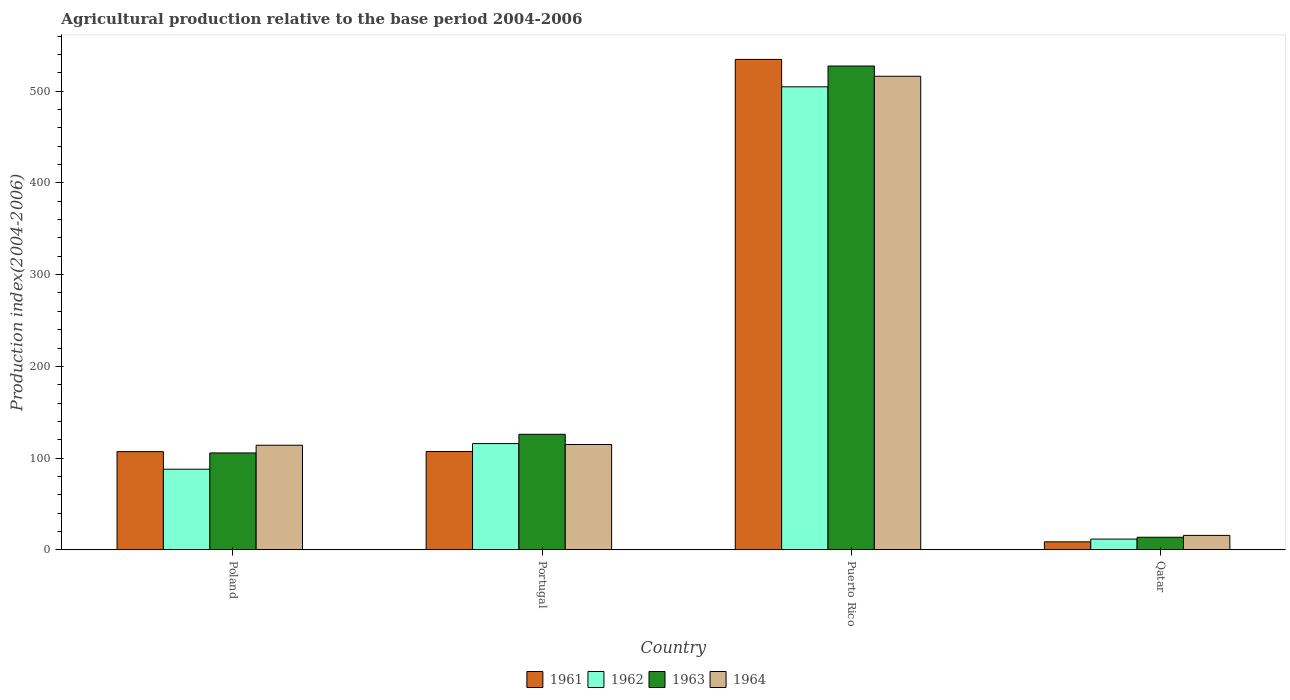How many different coloured bars are there?
Keep it short and to the point. 4. Are the number of bars per tick equal to the number of legend labels?
Offer a very short reply. Yes. How many bars are there on the 4th tick from the right?
Provide a succinct answer. 4. What is the label of the 3rd group of bars from the left?
Offer a terse response. Puerto Rico. What is the agricultural production index in 1961 in Portugal?
Provide a short and direct response. 107.18. Across all countries, what is the maximum agricultural production index in 1962?
Offer a terse response. 504.71. Across all countries, what is the minimum agricultural production index in 1961?
Offer a terse response. 8.73. In which country was the agricultural production index in 1961 maximum?
Your answer should be very brief. Puerto Rico. In which country was the agricultural production index in 1963 minimum?
Offer a very short reply. Qatar. What is the total agricultural production index in 1963 in the graph?
Ensure brevity in your answer.  772.68. What is the difference between the agricultural production index in 1962 in Poland and that in Qatar?
Give a very brief answer. 76.17. What is the difference between the agricultural production index in 1964 in Poland and the agricultural production index in 1963 in Portugal?
Your response must be concise. -11.92. What is the average agricultural production index in 1963 per country?
Your answer should be compact. 193.17. What is the difference between the agricultural production index of/in 1963 and agricultural production index of/in 1962 in Puerto Rico?
Offer a very short reply. 22.67. What is the ratio of the agricultural production index in 1964 in Portugal to that in Puerto Rico?
Offer a terse response. 0.22. Is the difference between the agricultural production index in 1963 in Poland and Qatar greater than the difference between the agricultural production index in 1962 in Poland and Qatar?
Make the answer very short. Yes. What is the difference between the highest and the second highest agricultural production index in 1961?
Make the answer very short. -0.13. What is the difference between the highest and the lowest agricultural production index in 1964?
Give a very brief answer. 500.47. In how many countries, is the agricultural production index in 1962 greater than the average agricultural production index in 1962 taken over all countries?
Your answer should be compact. 1. What does the 3rd bar from the left in Poland represents?
Offer a very short reply. 1963. What does the 1st bar from the right in Qatar represents?
Offer a terse response. 1964. How many bars are there?
Offer a terse response. 16. Are all the bars in the graph horizontal?
Your answer should be very brief. No. Are the values on the major ticks of Y-axis written in scientific E-notation?
Offer a very short reply. No. Does the graph contain any zero values?
Ensure brevity in your answer.  No. What is the title of the graph?
Make the answer very short. Agricultural production relative to the base period 2004-2006. Does "1974" appear as one of the legend labels in the graph?
Offer a very short reply. No. What is the label or title of the Y-axis?
Your answer should be very brief. Production index(2004-2006). What is the Production index(2004-2006) in 1961 in Poland?
Offer a terse response. 107.05. What is the Production index(2004-2006) of 1962 in Poland?
Your answer should be compact. 87.9. What is the Production index(2004-2006) in 1963 in Poland?
Ensure brevity in your answer.  105.61. What is the Production index(2004-2006) in 1964 in Poland?
Give a very brief answer. 114.03. What is the Production index(2004-2006) in 1961 in Portugal?
Provide a succinct answer. 107.18. What is the Production index(2004-2006) of 1962 in Portugal?
Your response must be concise. 115.82. What is the Production index(2004-2006) of 1963 in Portugal?
Your answer should be compact. 125.95. What is the Production index(2004-2006) in 1964 in Portugal?
Provide a short and direct response. 114.81. What is the Production index(2004-2006) in 1961 in Puerto Rico?
Ensure brevity in your answer.  534.58. What is the Production index(2004-2006) in 1962 in Puerto Rico?
Your answer should be very brief. 504.71. What is the Production index(2004-2006) of 1963 in Puerto Rico?
Your answer should be very brief. 527.38. What is the Production index(2004-2006) of 1964 in Puerto Rico?
Your answer should be compact. 516.21. What is the Production index(2004-2006) in 1961 in Qatar?
Offer a terse response. 8.73. What is the Production index(2004-2006) of 1962 in Qatar?
Offer a terse response. 11.73. What is the Production index(2004-2006) in 1963 in Qatar?
Provide a short and direct response. 13.74. What is the Production index(2004-2006) of 1964 in Qatar?
Ensure brevity in your answer.  15.74. Across all countries, what is the maximum Production index(2004-2006) of 1961?
Keep it short and to the point. 534.58. Across all countries, what is the maximum Production index(2004-2006) of 1962?
Your response must be concise. 504.71. Across all countries, what is the maximum Production index(2004-2006) of 1963?
Your response must be concise. 527.38. Across all countries, what is the maximum Production index(2004-2006) in 1964?
Offer a very short reply. 516.21. Across all countries, what is the minimum Production index(2004-2006) in 1961?
Your answer should be very brief. 8.73. Across all countries, what is the minimum Production index(2004-2006) of 1962?
Provide a succinct answer. 11.73. Across all countries, what is the minimum Production index(2004-2006) of 1963?
Give a very brief answer. 13.74. Across all countries, what is the minimum Production index(2004-2006) in 1964?
Your answer should be very brief. 15.74. What is the total Production index(2004-2006) of 1961 in the graph?
Keep it short and to the point. 757.54. What is the total Production index(2004-2006) in 1962 in the graph?
Offer a terse response. 720.16. What is the total Production index(2004-2006) in 1963 in the graph?
Keep it short and to the point. 772.68. What is the total Production index(2004-2006) in 1964 in the graph?
Your answer should be very brief. 760.79. What is the difference between the Production index(2004-2006) in 1961 in Poland and that in Portugal?
Your answer should be very brief. -0.13. What is the difference between the Production index(2004-2006) in 1962 in Poland and that in Portugal?
Give a very brief answer. -27.92. What is the difference between the Production index(2004-2006) of 1963 in Poland and that in Portugal?
Keep it short and to the point. -20.34. What is the difference between the Production index(2004-2006) in 1964 in Poland and that in Portugal?
Your response must be concise. -0.78. What is the difference between the Production index(2004-2006) of 1961 in Poland and that in Puerto Rico?
Keep it short and to the point. -427.53. What is the difference between the Production index(2004-2006) of 1962 in Poland and that in Puerto Rico?
Make the answer very short. -416.81. What is the difference between the Production index(2004-2006) of 1963 in Poland and that in Puerto Rico?
Ensure brevity in your answer.  -421.77. What is the difference between the Production index(2004-2006) of 1964 in Poland and that in Puerto Rico?
Offer a terse response. -402.18. What is the difference between the Production index(2004-2006) in 1961 in Poland and that in Qatar?
Your answer should be very brief. 98.32. What is the difference between the Production index(2004-2006) in 1962 in Poland and that in Qatar?
Keep it short and to the point. 76.17. What is the difference between the Production index(2004-2006) in 1963 in Poland and that in Qatar?
Provide a succinct answer. 91.87. What is the difference between the Production index(2004-2006) of 1964 in Poland and that in Qatar?
Ensure brevity in your answer.  98.29. What is the difference between the Production index(2004-2006) of 1961 in Portugal and that in Puerto Rico?
Give a very brief answer. -427.4. What is the difference between the Production index(2004-2006) in 1962 in Portugal and that in Puerto Rico?
Your response must be concise. -388.89. What is the difference between the Production index(2004-2006) in 1963 in Portugal and that in Puerto Rico?
Keep it short and to the point. -401.43. What is the difference between the Production index(2004-2006) in 1964 in Portugal and that in Puerto Rico?
Offer a very short reply. -401.4. What is the difference between the Production index(2004-2006) in 1961 in Portugal and that in Qatar?
Provide a short and direct response. 98.45. What is the difference between the Production index(2004-2006) of 1962 in Portugal and that in Qatar?
Keep it short and to the point. 104.09. What is the difference between the Production index(2004-2006) in 1963 in Portugal and that in Qatar?
Give a very brief answer. 112.21. What is the difference between the Production index(2004-2006) of 1964 in Portugal and that in Qatar?
Provide a succinct answer. 99.07. What is the difference between the Production index(2004-2006) in 1961 in Puerto Rico and that in Qatar?
Ensure brevity in your answer.  525.85. What is the difference between the Production index(2004-2006) of 1962 in Puerto Rico and that in Qatar?
Your response must be concise. 492.98. What is the difference between the Production index(2004-2006) in 1963 in Puerto Rico and that in Qatar?
Provide a short and direct response. 513.64. What is the difference between the Production index(2004-2006) of 1964 in Puerto Rico and that in Qatar?
Your response must be concise. 500.47. What is the difference between the Production index(2004-2006) in 1961 in Poland and the Production index(2004-2006) in 1962 in Portugal?
Your answer should be compact. -8.77. What is the difference between the Production index(2004-2006) of 1961 in Poland and the Production index(2004-2006) of 1963 in Portugal?
Offer a very short reply. -18.9. What is the difference between the Production index(2004-2006) in 1961 in Poland and the Production index(2004-2006) in 1964 in Portugal?
Keep it short and to the point. -7.76. What is the difference between the Production index(2004-2006) of 1962 in Poland and the Production index(2004-2006) of 1963 in Portugal?
Provide a succinct answer. -38.05. What is the difference between the Production index(2004-2006) in 1962 in Poland and the Production index(2004-2006) in 1964 in Portugal?
Your answer should be very brief. -26.91. What is the difference between the Production index(2004-2006) of 1961 in Poland and the Production index(2004-2006) of 1962 in Puerto Rico?
Offer a terse response. -397.66. What is the difference between the Production index(2004-2006) in 1961 in Poland and the Production index(2004-2006) in 1963 in Puerto Rico?
Keep it short and to the point. -420.33. What is the difference between the Production index(2004-2006) of 1961 in Poland and the Production index(2004-2006) of 1964 in Puerto Rico?
Offer a terse response. -409.16. What is the difference between the Production index(2004-2006) of 1962 in Poland and the Production index(2004-2006) of 1963 in Puerto Rico?
Offer a very short reply. -439.48. What is the difference between the Production index(2004-2006) in 1962 in Poland and the Production index(2004-2006) in 1964 in Puerto Rico?
Ensure brevity in your answer.  -428.31. What is the difference between the Production index(2004-2006) of 1963 in Poland and the Production index(2004-2006) of 1964 in Puerto Rico?
Keep it short and to the point. -410.6. What is the difference between the Production index(2004-2006) of 1961 in Poland and the Production index(2004-2006) of 1962 in Qatar?
Provide a succinct answer. 95.32. What is the difference between the Production index(2004-2006) in 1961 in Poland and the Production index(2004-2006) in 1963 in Qatar?
Your answer should be compact. 93.31. What is the difference between the Production index(2004-2006) of 1961 in Poland and the Production index(2004-2006) of 1964 in Qatar?
Offer a terse response. 91.31. What is the difference between the Production index(2004-2006) in 1962 in Poland and the Production index(2004-2006) in 1963 in Qatar?
Your answer should be compact. 74.16. What is the difference between the Production index(2004-2006) of 1962 in Poland and the Production index(2004-2006) of 1964 in Qatar?
Provide a succinct answer. 72.16. What is the difference between the Production index(2004-2006) in 1963 in Poland and the Production index(2004-2006) in 1964 in Qatar?
Your response must be concise. 89.87. What is the difference between the Production index(2004-2006) in 1961 in Portugal and the Production index(2004-2006) in 1962 in Puerto Rico?
Provide a short and direct response. -397.53. What is the difference between the Production index(2004-2006) in 1961 in Portugal and the Production index(2004-2006) in 1963 in Puerto Rico?
Make the answer very short. -420.2. What is the difference between the Production index(2004-2006) in 1961 in Portugal and the Production index(2004-2006) in 1964 in Puerto Rico?
Keep it short and to the point. -409.03. What is the difference between the Production index(2004-2006) in 1962 in Portugal and the Production index(2004-2006) in 1963 in Puerto Rico?
Ensure brevity in your answer.  -411.56. What is the difference between the Production index(2004-2006) in 1962 in Portugal and the Production index(2004-2006) in 1964 in Puerto Rico?
Your answer should be very brief. -400.39. What is the difference between the Production index(2004-2006) in 1963 in Portugal and the Production index(2004-2006) in 1964 in Puerto Rico?
Keep it short and to the point. -390.26. What is the difference between the Production index(2004-2006) of 1961 in Portugal and the Production index(2004-2006) of 1962 in Qatar?
Make the answer very short. 95.45. What is the difference between the Production index(2004-2006) of 1961 in Portugal and the Production index(2004-2006) of 1963 in Qatar?
Provide a succinct answer. 93.44. What is the difference between the Production index(2004-2006) in 1961 in Portugal and the Production index(2004-2006) in 1964 in Qatar?
Ensure brevity in your answer.  91.44. What is the difference between the Production index(2004-2006) of 1962 in Portugal and the Production index(2004-2006) of 1963 in Qatar?
Your response must be concise. 102.08. What is the difference between the Production index(2004-2006) in 1962 in Portugal and the Production index(2004-2006) in 1964 in Qatar?
Keep it short and to the point. 100.08. What is the difference between the Production index(2004-2006) in 1963 in Portugal and the Production index(2004-2006) in 1964 in Qatar?
Provide a short and direct response. 110.21. What is the difference between the Production index(2004-2006) in 1961 in Puerto Rico and the Production index(2004-2006) in 1962 in Qatar?
Provide a short and direct response. 522.85. What is the difference between the Production index(2004-2006) of 1961 in Puerto Rico and the Production index(2004-2006) of 1963 in Qatar?
Your answer should be compact. 520.84. What is the difference between the Production index(2004-2006) of 1961 in Puerto Rico and the Production index(2004-2006) of 1964 in Qatar?
Your answer should be very brief. 518.84. What is the difference between the Production index(2004-2006) in 1962 in Puerto Rico and the Production index(2004-2006) in 1963 in Qatar?
Provide a short and direct response. 490.97. What is the difference between the Production index(2004-2006) in 1962 in Puerto Rico and the Production index(2004-2006) in 1964 in Qatar?
Keep it short and to the point. 488.97. What is the difference between the Production index(2004-2006) of 1963 in Puerto Rico and the Production index(2004-2006) of 1964 in Qatar?
Your response must be concise. 511.64. What is the average Production index(2004-2006) of 1961 per country?
Your answer should be very brief. 189.38. What is the average Production index(2004-2006) of 1962 per country?
Make the answer very short. 180.04. What is the average Production index(2004-2006) in 1963 per country?
Keep it short and to the point. 193.17. What is the average Production index(2004-2006) in 1964 per country?
Ensure brevity in your answer.  190.2. What is the difference between the Production index(2004-2006) in 1961 and Production index(2004-2006) in 1962 in Poland?
Give a very brief answer. 19.15. What is the difference between the Production index(2004-2006) of 1961 and Production index(2004-2006) of 1963 in Poland?
Offer a very short reply. 1.44. What is the difference between the Production index(2004-2006) of 1961 and Production index(2004-2006) of 1964 in Poland?
Provide a short and direct response. -6.98. What is the difference between the Production index(2004-2006) in 1962 and Production index(2004-2006) in 1963 in Poland?
Keep it short and to the point. -17.71. What is the difference between the Production index(2004-2006) of 1962 and Production index(2004-2006) of 1964 in Poland?
Your answer should be very brief. -26.13. What is the difference between the Production index(2004-2006) in 1963 and Production index(2004-2006) in 1964 in Poland?
Give a very brief answer. -8.42. What is the difference between the Production index(2004-2006) in 1961 and Production index(2004-2006) in 1962 in Portugal?
Your response must be concise. -8.64. What is the difference between the Production index(2004-2006) of 1961 and Production index(2004-2006) of 1963 in Portugal?
Your response must be concise. -18.77. What is the difference between the Production index(2004-2006) in 1961 and Production index(2004-2006) in 1964 in Portugal?
Keep it short and to the point. -7.63. What is the difference between the Production index(2004-2006) of 1962 and Production index(2004-2006) of 1963 in Portugal?
Offer a terse response. -10.13. What is the difference between the Production index(2004-2006) of 1962 and Production index(2004-2006) of 1964 in Portugal?
Give a very brief answer. 1.01. What is the difference between the Production index(2004-2006) in 1963 and Production index(2004-2006) in 1964 in Portugal?
Offer a terse response. 11.14. What is the difference between the Production index(2004-2006) in 1961 and Production index(2004-2006) in 1962 in Puerto Rico?
Ensure brevity in your answer.  29.87. What is the difference between the Production index(2004-2006) in 1961 and Production index(2004-2006) in 1964 in Puerto Rico?
Make the answer very short. 18.37. What is the difference between the Production index(2004-2006) of 1962 and Production index(2004-2006) of 1963 in Puerto Rico?
Provide a short and direct response. -22.67. What is the difference between the Production index(2004-2006) of 1963 and Production index(2004-2006) of 1964 in Puerto Rico?
Keep it short and to the point. 11.17. What is the difference between the Production index(2004-2006) in 1961 and Production index(2004-2006) in 1962 in Qatar?
Provide a short and direct response. -3. What is the difference between the Production index(2004-2006) in 1961 and Production index(2004-2006) in 1963 in Qatar?
Your response must be concise. -5.01. What is the difference between the Production index(2004-2006) of 1961 and Production index(2004-2006) of 1964 in Qatar?
Give a very brief answer. -7.01. What is the difference between the Production index(2004-2006) of 1962 and Production index(2004-2006) of 1963 in Qatar?
Your answer should be compact. -2.01. What is the difference between the Production index(2004-2006) in 1962 and Production index(2004-2006) in 1964 in Qatar?
Provide a short and direct response. -4.01. What is the difference between the Production index(2004-2006) of 1963 and Production index(2004-2006) of 1964 in Qatar?
Your answer should be very brief. -2. What is the ratio of the Production index(2004-2006) in 1961 in Poland to that in Portugal?
Offer a very short reply. 1. What is the ratio of the Production index(2004-2006) of 1962 in Poland to that in Portugal?
Offer a terse response. 0.76. What is the ratio of the Production index(2004-2006) in 1963 in Poland to that in Portugal?
Your answer should be very brief. 0.84. What is the ratio of the Production index(2004-2006) of 1961 in Poland to that in Puerto Rico?
Offer a terse response. 0.2. What is the ratio of the Production index(2004-2006) of 1962 in Poland to that in Puerto Rico?
Make the answer very short. 0.17. What is the ratio of the Production index(2004-2006) in 1963 in Poland to that in Puerto Rico?
Provide a short and direct response. 0.2. What is the ratio of the Production index(2004-2006) in 1964 in Poland to that in Puerto Rico?
Your answer should be compact. 0.22. What is the ratio of the Production index(2004-2006) in 1961 in Poland to that in Qatar?
Make the answer very short. 12.26. What is the ratio of the Production index(2004-2006) of 1962 in Poland to that in Qatar?
Offer a terse response. 7.49. What is the ratio of the Production index(2004-2006) in 1963 in Poland to that in Qatar?
Provide a succinct answer. 7.69. What is the ratio of the Production index(2004-2006) in 1964 in Poland to that in Qatar?
Offer a very short reply. 7.24. What is the ratio of the Production index(2004-2006) in 1961 in Portugal to that in Puerto Rico?
Give a very brief answer. 0.2. What is the ratio of the Production index(2004-2006) in 1962 in Portugal to that in Puerto Rico?
Provide a succinct answer. 0.23. What is the ratio of the Production index(2004-2006) of 1963 in Portugal to that in Puerto Rico?
Provide a short and direct response. 0.24. What is the ratio of the Production index(2004-2006) in 1964 in Portugal to that in Puerto Rico?
Your answer should be very brief. 0.22. What is the ratio of the Production index(2004-2006) in 1961 in Portugal to that in Qatar?
Give a very brief answer. 12.28. What is the ratio of the Production index(2004-2006) in 1962 in Portugal to that in Qatar?
Your answer should be very brief. 9.87. What is the ratio of the Production index(2004-2006) in 1963 in Portugal to that in Qatar?
Your answer should be compact. 9.17. What is the ratio of the Production index(2004-2006) of 1964 in Portugal to that in Qatar?
Provide a short and direct response. 7.29. What is the ratio of the Production index(2004-2006) of 1961 in Puerto Rico to that in Qatar?
Your answer should be compact. 61.23. What is the ratio of the Production index(2004-2006) in 1962 in Puerto Rico to that in Qatar?
Your response must be concise. 43.03. What is the ratio of the Production index(2004-2006) in 1963 in Puerto Rico to that in Qatar?
Offer a very short reply. 38.38. What is the ratio of the Production index(2004-2006) of 1964 in Puerto Rico to that in Qatar?
Ensure brevity in your answer.  32.8. What is the difference between the highest and the second highest Production index(2004-2006) in 1961?
Provide a short and direct response. 427.4. What is the difference between the highest and the second highest Production index(2004-2006) of 1962?
Keep it short and to the point. 388.89. What is the difference between the highest and the second highest Production index(2004-2006) of 1963?
Your response must be concise. 401.43. What is the difference between the highest and the second highest Production index(2004-2006) in 1964?
Give a very brief answer. 401.4. What is the difference between the highest and the lowest Production index(2004-2006) of 1961?
Ensure brevity in your answer.  525.85. What is the difference between the highest and the lowest Production index(2004-2006) of 1962?
Your answer should be compact. 492.98. What is the difference between the highest and the lowest Production index(2004-2006) in 1963?
Provide a short and direct response. 513.64. What is the difference between the highest and the lowest Production index(2004-2006) of 1964?
Make the answer very short. 500.47. 